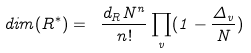Convert formula to latex. <formula><loc_0><loc_0><loc_500><loc_500>d i m ( R ^ { * } ) = \ \frac { d _ { R } N ^ { n } } { n ! } \prod _ { v } ( 1 - \frac { \Delta _ { v } } { N } )</formula> 